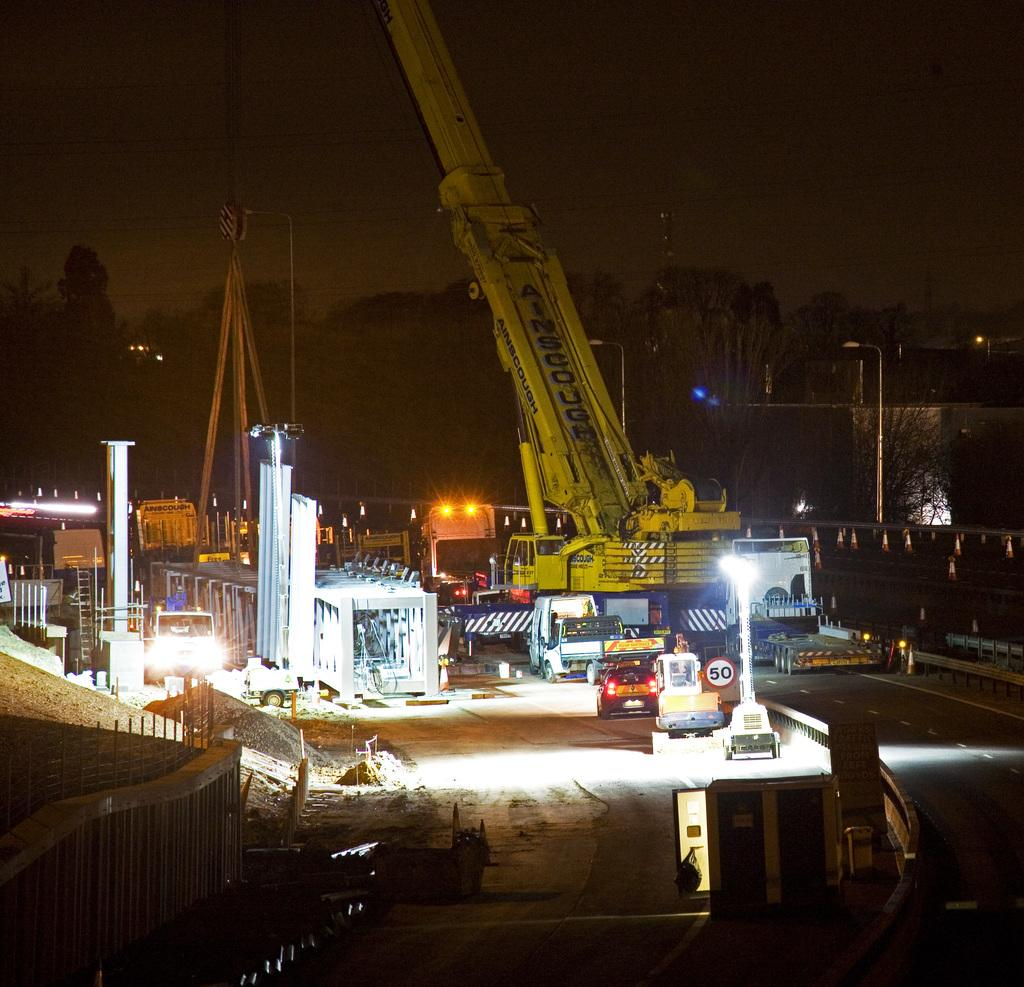What types of objects are present in the image? There are vehicles and light poles in the image. What can be seen in the background of the image? There are buildings in the background of the image. What is the color of the sky in the image? The sky is black in color. Where are the children playing in the image? There are no children present in the image. How many frogs can be seen on the stage in the image? There is no stage or frogs present in the image. 